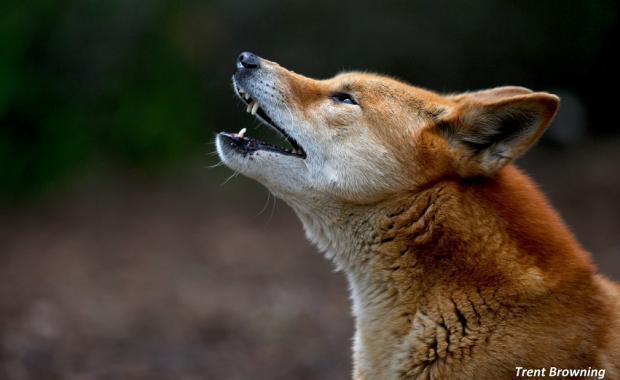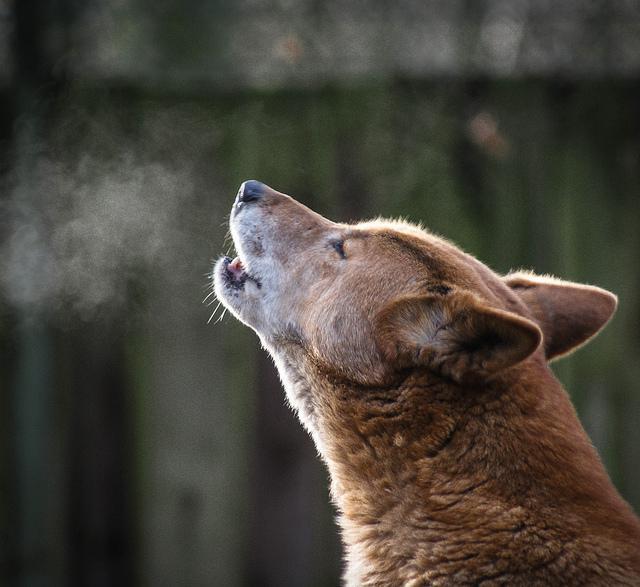The first image is the image on the left, the second image is the image on the right. Considering the images on both sides, is "An image contains at least two canines." valid? Answer yes or no. No. The first image is the image on the left, the second image is the image on the right. Assess this claim about the two images: "Some of the dingoes are howling.". Correct or not? Answer yes or no. Yes. 